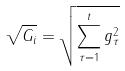<formula> <loc_0><loc_0><loc_500><loc_500>\sqrt { G _ { i } } = \sqrt { \sum _ { \tau = 1 } ^ { t } g _ { \tau } ^ { 2 } }</formula> 